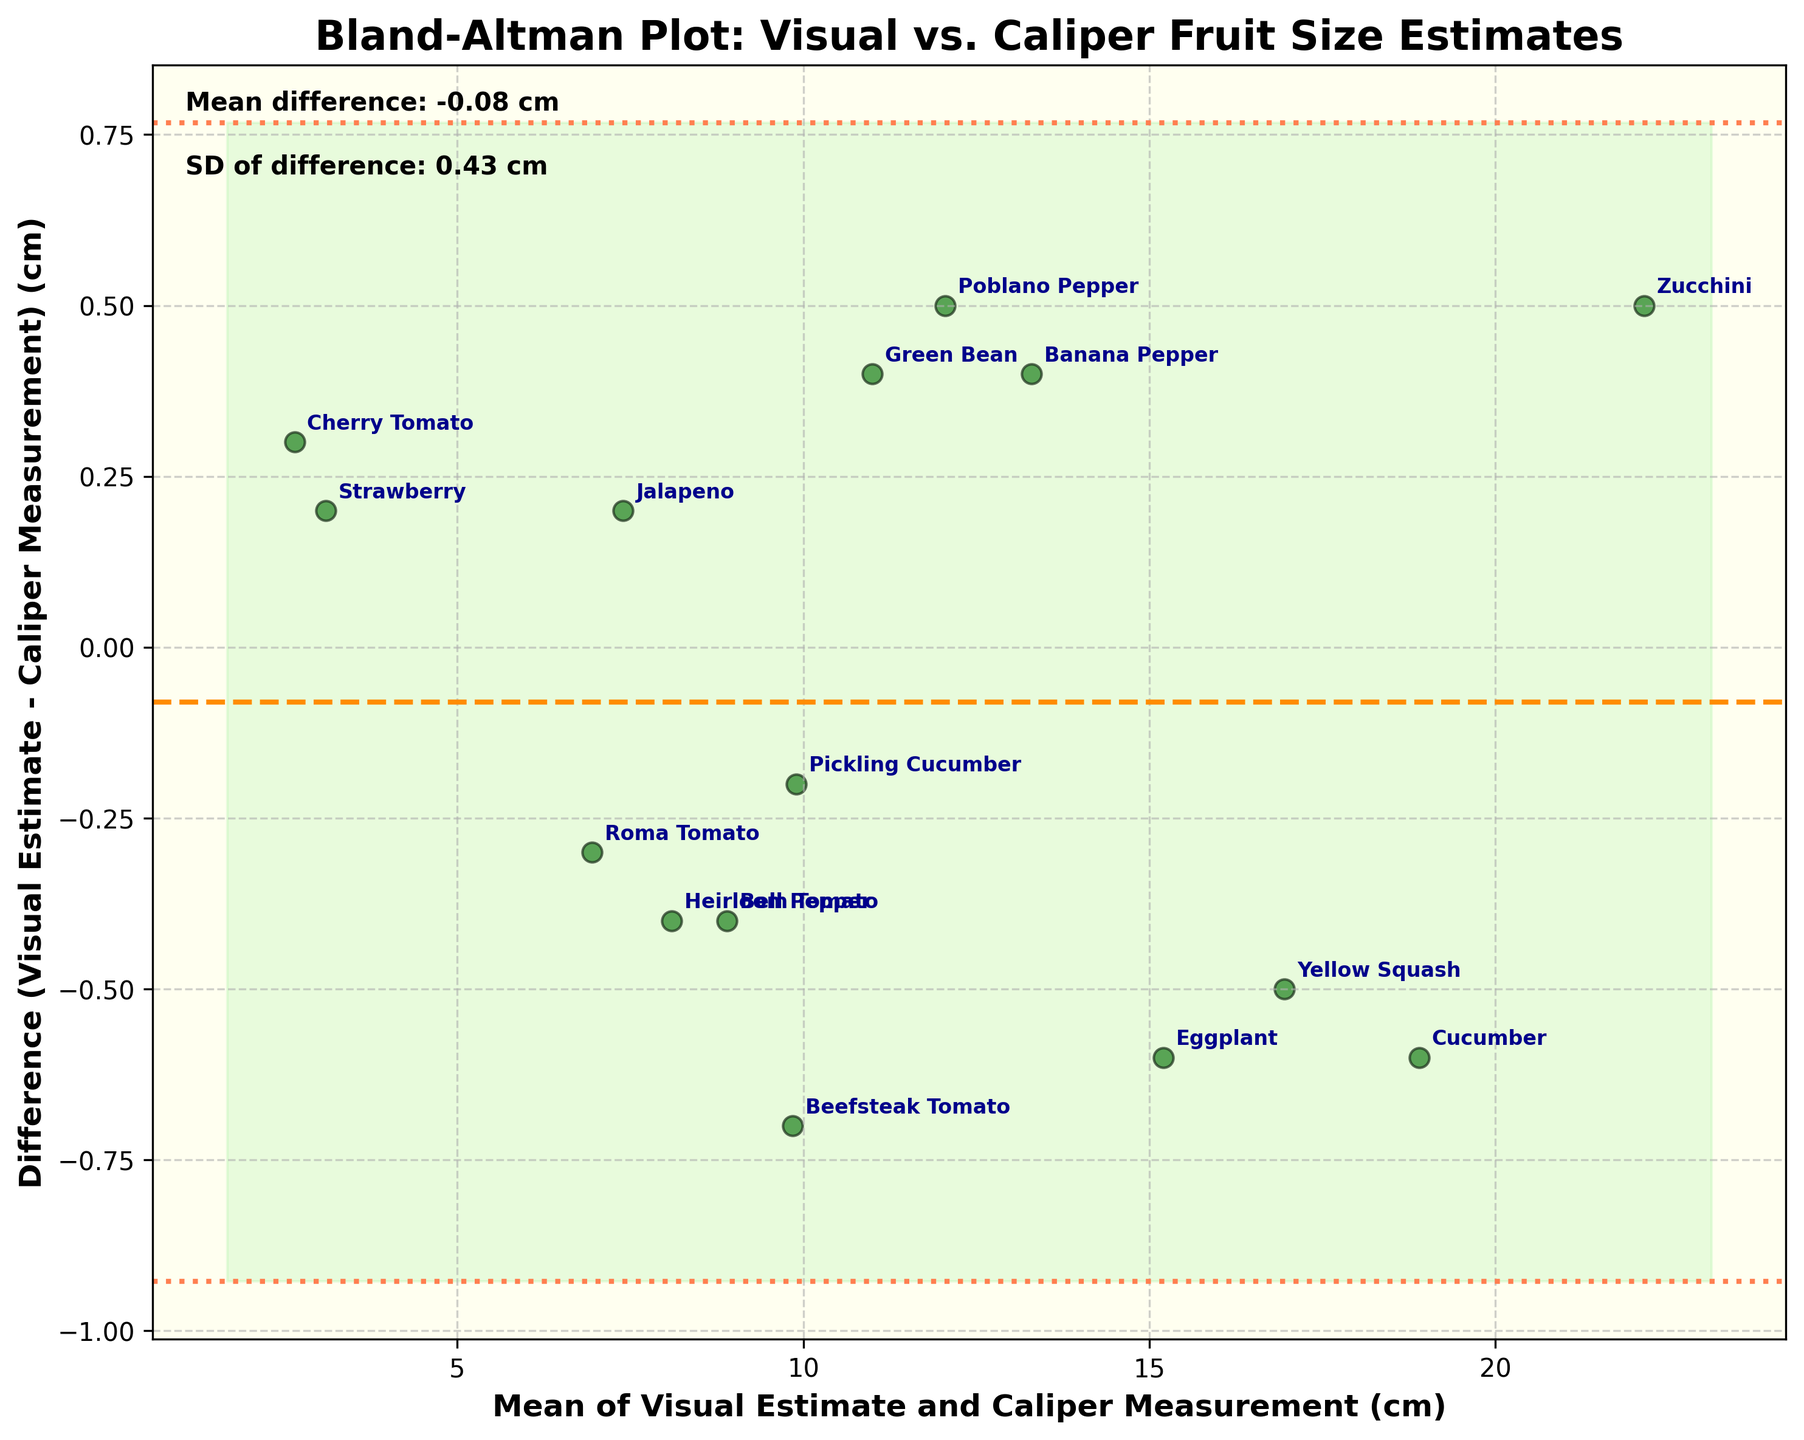What is the title of the figure? The title can be found at the top of the figure. It is usually in a larger and bold font to stand out. In this case, "Bland-Altman Plot: Visual vs. Caliper Fruit Size Estimates" is the title.
Answer: Bland-Altman Plot: Visual vs. Caliper Fruit Size Estimates How many data points are shown in the figure? Each data point in the figure represents a fruit's measurement. By counting the number of distinct scatter points, we determine there are 15 data points.
Answer: 15 What do the horizontal dashed and dotted lines represent? The dashed line represents the mean difference between visual estimates and caliper measurements, while the dotted lines correspond to the limits of agreement (mean difference ± 1.96 times the standard deviation of the differences).
Answer: The dashed line represents the mean difference, and the dotted lines represent the limits of agreement What is the mean difference between visual estimates and caliper measurements? The mean difference can be seen in the annotation text placed near the top left of the plot. It provides the statistical information directly.
Answer: 0.11 cm Which fruit has the largest positive difference between visual estimate and caliper measurement? To find the fruit with the largest positive difference, look at the highest point above the mean difference line, then refer to the annotation or label close to that point.
Answer: Beefsteak Tomato Which fruit has the largest negative difference between visual estimate and caliper measurement? Identify the lowest point below the mean difference line. The label closest to this point will indicate which fruit has the most substantial negative difference.
Answer: Green Bean How do the limits of agreement help in evaluating the measurements? The limits of agreement (mean difference ± 1.96 times the standard deviation) provide an interval within which most differences between the two measurement methods are expected to fall, suggesting the extent of agreement or variability between these methods.
Answer: They show the range where most differences fall What is the range of the mean of measurements? The range of the mean of measurements can be determined by looking at the x-axis. The minimum mean is around 2.6 cm, and the maximum is about 22.15 cm. Calculate the difference: 22.15 cm - 2.6 cm.
Answer: 19.55 cm What is the standard deviation of the differences (as given in the plot)? The standard deviation of the differences is annotated on the plot, near the mean difference annotation. It is directly provided for quick reference.
Answer: 0.98 cm Do visual estimates tend to overestimate or underestimate fruit size compared to caliper measurements? By examining the placement of most data points concerning the mean difference line (0.11 cm), we see that more points are slightly above it. This suggests that visual estimates slightly overestimate fruit size when compared to caliper measurements.
Answer: Overestimate 